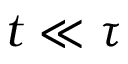Convert formula to latex. <formula><loc_0><loc_0><loc_500><loc_500>t \ll \tau</formula> 